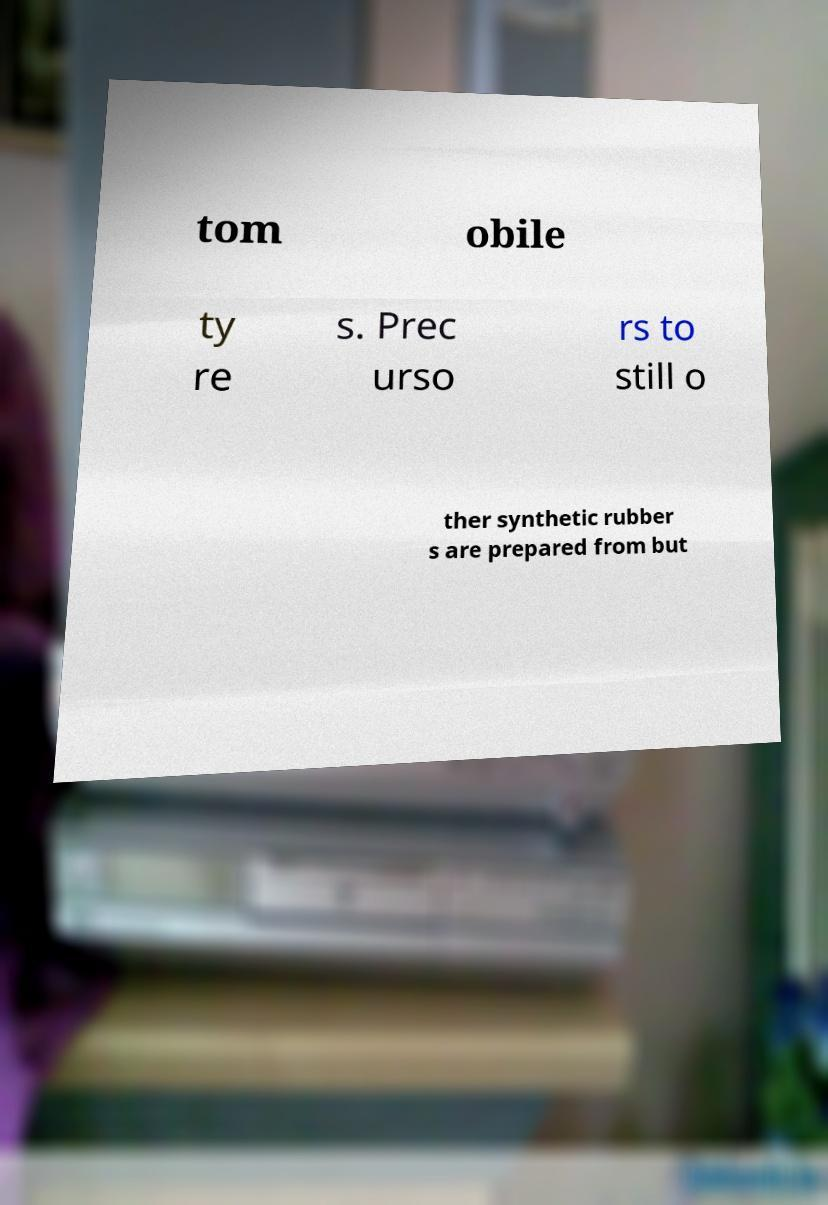Can you accurately transcribe the text from the provided image for me? tom obile ty re s. Prec urso rs to still o ther synthetic rubber s are prepared from but 